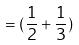Convert formula to latex. <formula><loc_0><loc_0><loc_500><loc_500>= ( \frac { 1 } { 2 } + \frac { 1 } { 3 } )</formula> 